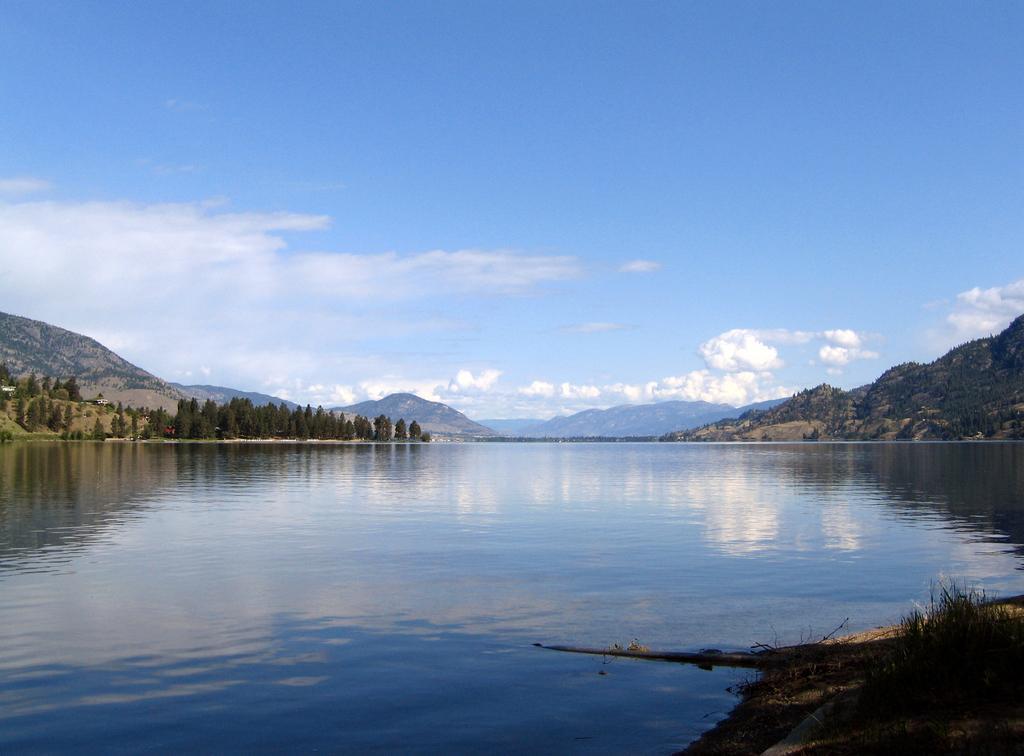Please provide a concise description of this image. In the image there is a lake in the front with hills and trees behind it and above its sky with clouds. 